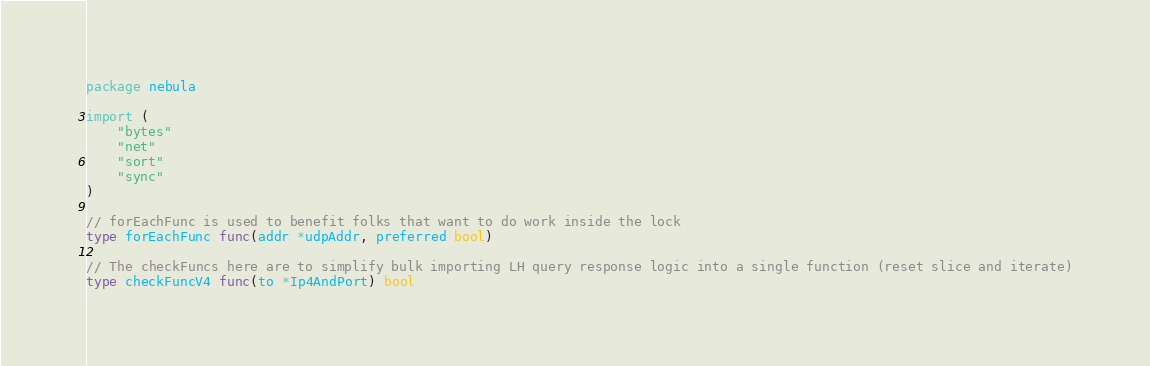Convert code to text. <code><loc_0><loc_0><loc_500><loc_500><_Go_>package nebula

import (
	"bytes"
	"net"
	"sort"
	"sync"
)

// forEachFunc is used to benefit folks that want to do work inside the lock
type forEachFunc func(addr *udpAddr, preferred bool)

// The checkFuncs here are to simplify bulk importing LH query response logic into a single function (reset slice and iterate)
type checkFuncV4 func(to *Ip4AndPort) bool</code> 